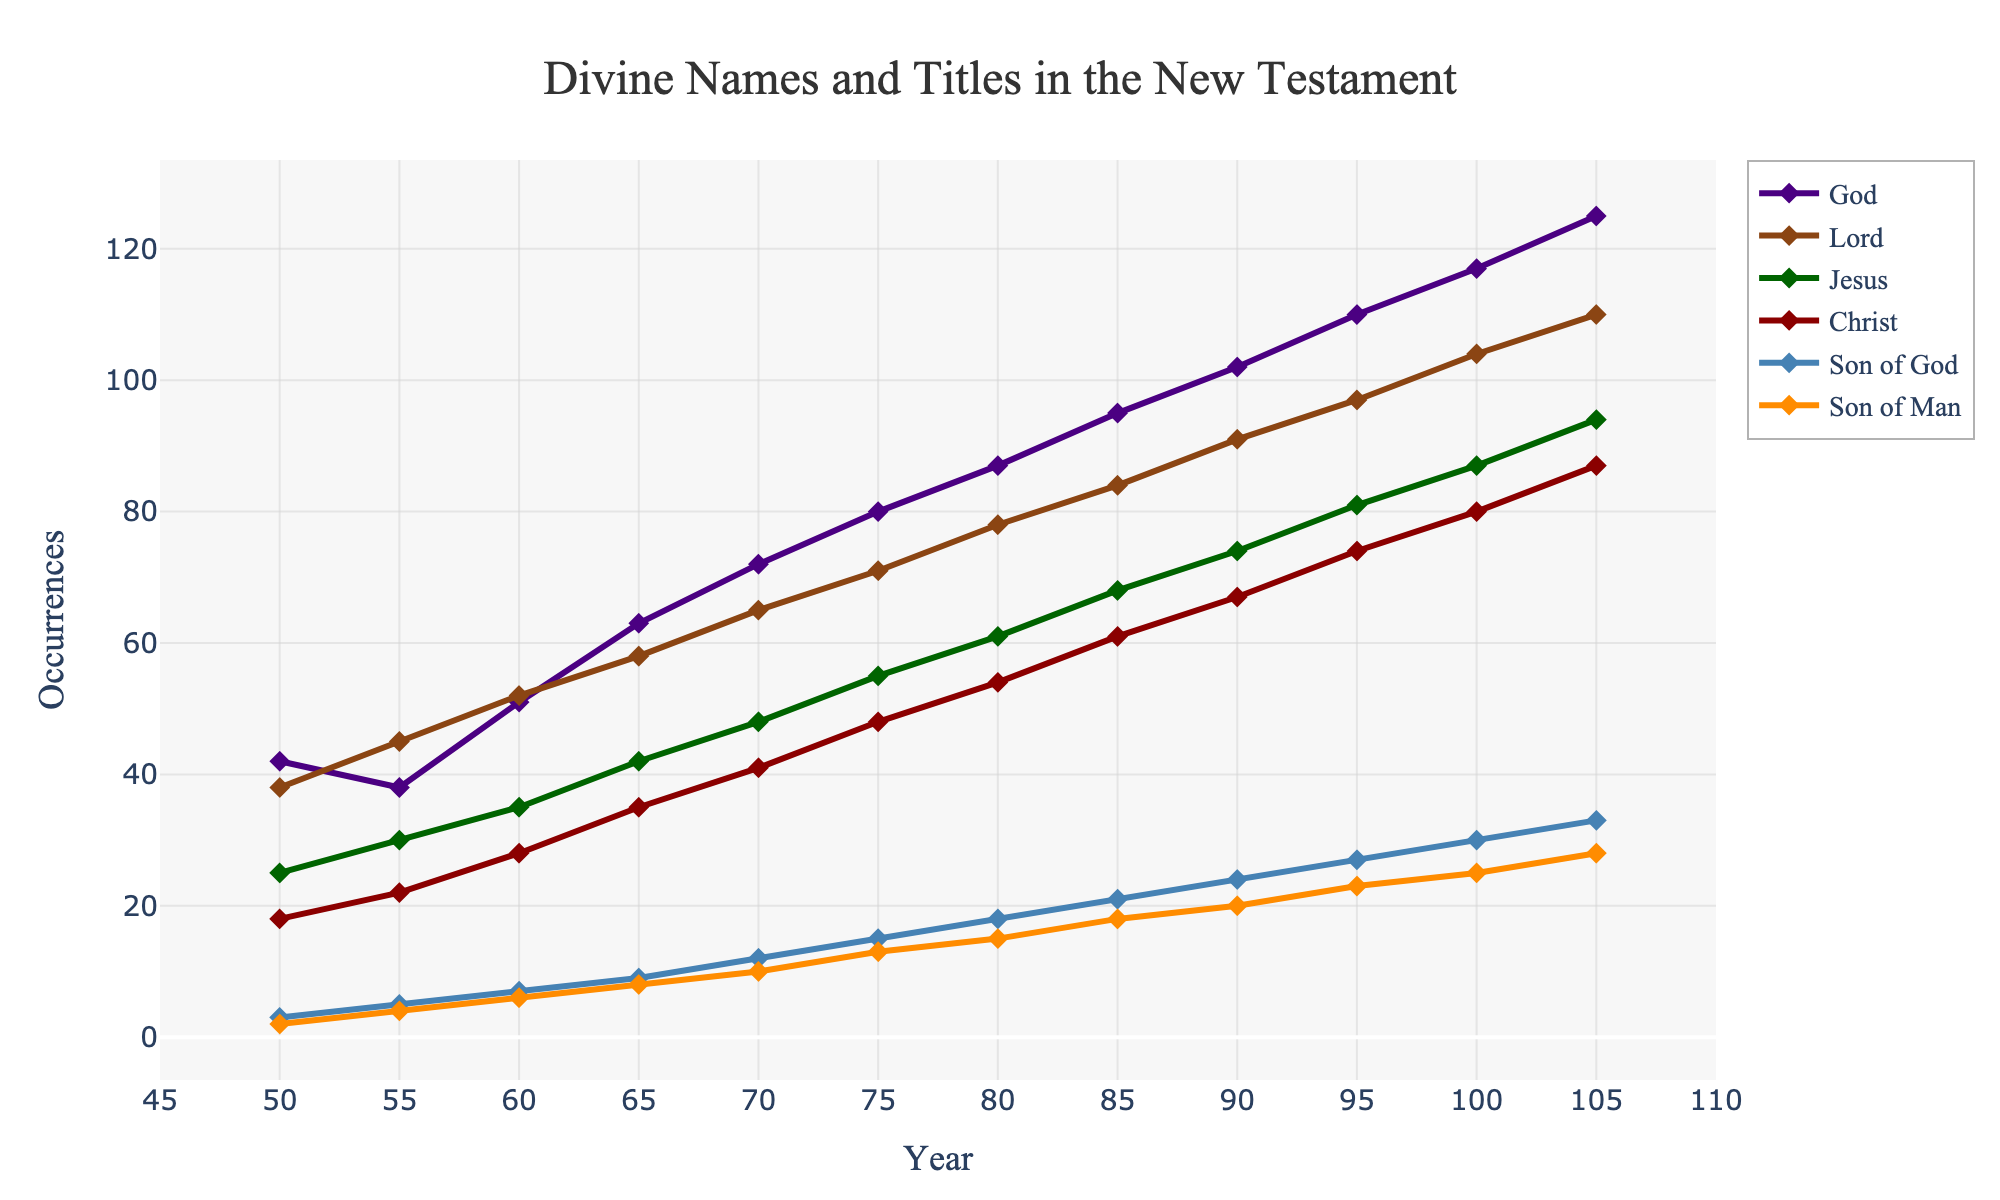What divine name or title increases the most in frequency from the year 50 to the year 105? To find the answer, we need to calculate the increase for each divine name or title from 50 to 105, and compare these increases. The increases are: 'God' (125-42=83), 'Lord' (110-38=72), 'Jesus' (94-25=69), 'Christ' (87-18=69), 'Son of God' (33-3=30), 'Son of Man' (28-2=26). 'God' has the highest increase with 83 occurrences.
Answer: 'God' Which divine name or title has the least occurrences overall in the year 75? Look at the frequencies for the year 75 for each title and find the smallest one. The frequencies are: 'God' (80), 'Lord' (71), 'Jesus' (55), 'Christ' (48), 'Son of God' (15), 'Son of Man' (13). 'Son of Man' has the least occurrences with 13.
Answer: 'Son of Man' Between the years 70 and 85, which divine name or title shows the greatest increase in occurrences? Calculate the increase for each title between these years. The differences are: 'God' (95-72=23), 'Lord' (84-65=19), 'Jesus' (68-48=20), 'Christ' (61-41=20), 'Son of God' (21-12=9), 'Son of Man' (18-10=8). The greatest increase is for 'God' with a difference of 23 occurrences.
Answer: 'God' In the year 90, which divine name or title has the highest frequency? Examine the frequencies in 90 for each title: 'God' (102), 'Lord' (91), 'Jesus' (74), 'Christ' (67), 'Son of God' (24), 'Son of Man' (20). 'God' has the highest frequency with 102 occurrences.
Answer: 'God' What is the total number of occurrences for the title 'Jesus' between the years 50 and 100? Sum the frequencies of 'Jesus' from the years 50, 55, 60, 65, 70, 75, 80, 85, 90, 95, and 100. The values are: 25 + 30 + 35 + 42 + 48 + 55 + 61 + 68 + 74 + 81 + 87 = 606.
Answer: 606 Which two titles show equal frequencies in the year 85? Check the frequencies for all titles in the year 85: 'God' (95), 'Lord' (84), 'Jesus' (68), 'Christ' (61), 'Son of God' (21), 'Son of Man' (18). No two titles have the same frequency in that year.
Answer: None In which year does the title 'Lord' first exceed 50 occurrences? Identify the first year in the 'Lord' column where the value exceeds 50. The values are: 38 (50), 45 (55), 52 (60), 58 (65). The first year when 'Lord' exceeds 50 is 60.
Answer: 60 How does the frequency of 'Christ' in the year 105 compare to 'Son of Man' in the year 90? Examine the values: 'Christ' in 105 (87) and 'Son of Man' in 90 (20). 'Christ' in 105 has 87 occurrences while 'Son of Man' in 90 has 20. 'Christ' in 105 is greater than 'Son of Man' in 90.
Answer: 'Christ' in 105 > 'Son of Man' in 90 What is the average increase in occurrences per title per decade from 50 to 100 for the title 'Son of God'? First, find the increase for each decade: 5 (55-50), 7 (60-55), 8 (65-60), 10 (70-65), 12 (75-70), 13 (80-75), 15 (85-80), 18 (90-85), 20 (95-90), 23 (100-95). Calculate the average of these increases: (5 + 7 + 8 + 10 + 12 + 13 + 15 + 18 + 20 + 23) / 10 = 13.1.
Answer: 13.1 